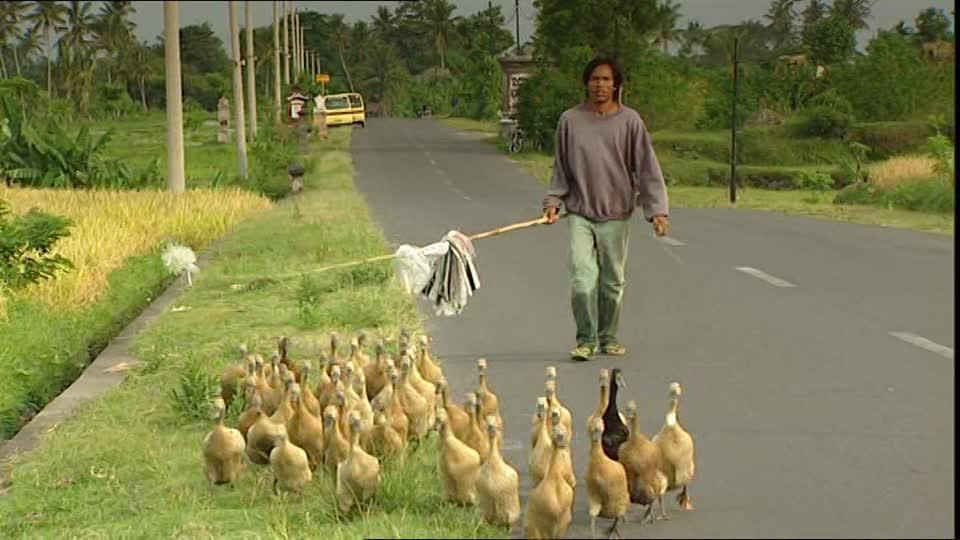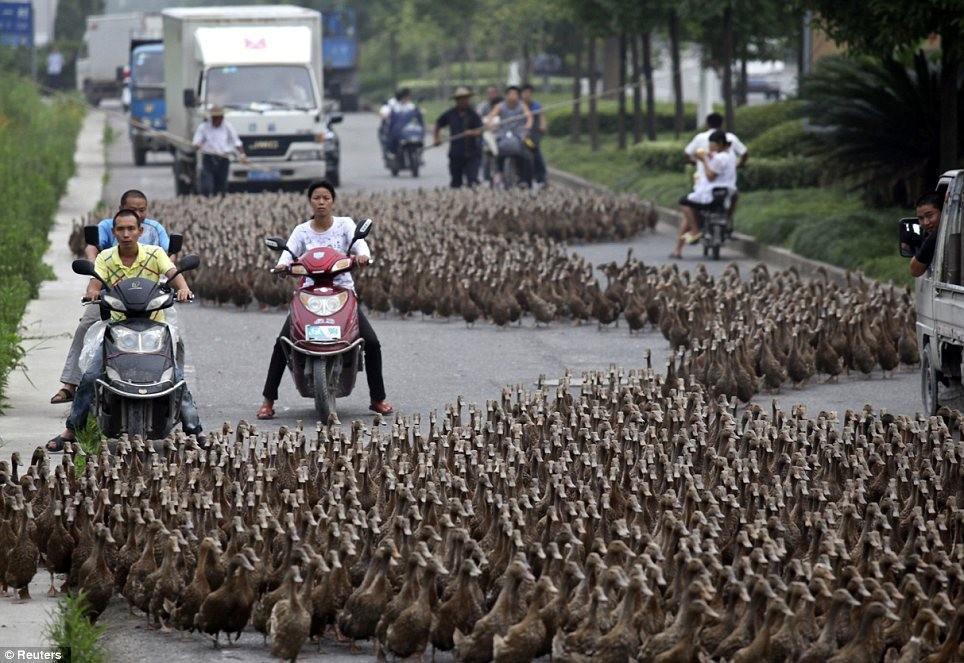The first image is the image on the left, the second image is the image on the right. Considering the images on both sides, is "One image shows a dog standing on grass behind a small flock of duck-like birds." valid? Answer yes or no. No. The first image is the image on the left, the second image is the image on the right. Examine the images to the left and right. Is the description "A single woman is standing with birds in the image on the left." accurate? Answer yes or no. Yes. 